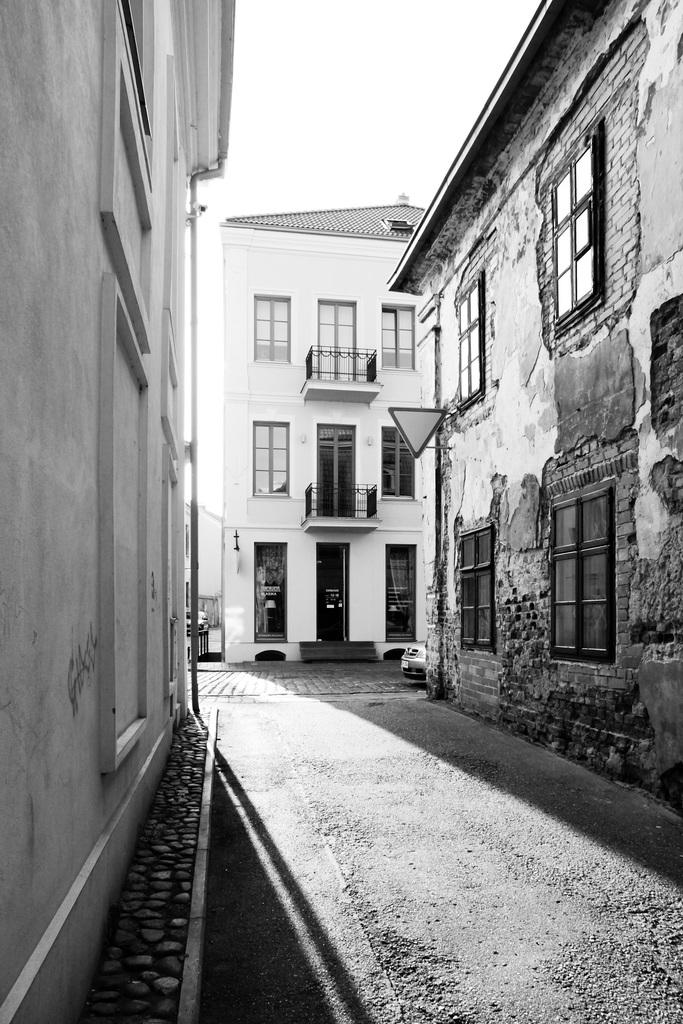What is the color scheme of the image? The image is black and white. What can be seen at the bottom of the image? There is a road at the bottom of the image. What is visible in the background of the image? There are buildings in the background of the image. What is visible at the top of the image? The sky is visible at the top of the image. Can you hear the marble crying in the image? There is no marble or any indication of sound in the image, as it is a black and white image featuring a road, buildings, and the sky. 